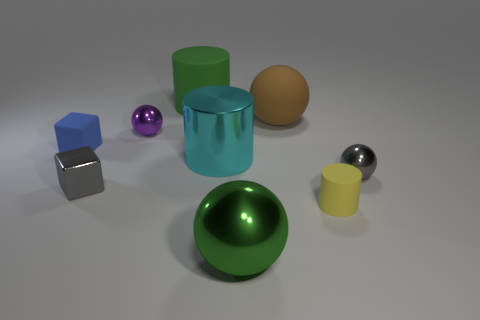Which objects in the picture appear to have a reflective surface? The objects with reflective surfaces in the image include the large metal sphere, the small purple sphere, and the small metallic cube. Their shiny textures allow them to reflect light and surrounding objects, giving them a mirrored appearance. 